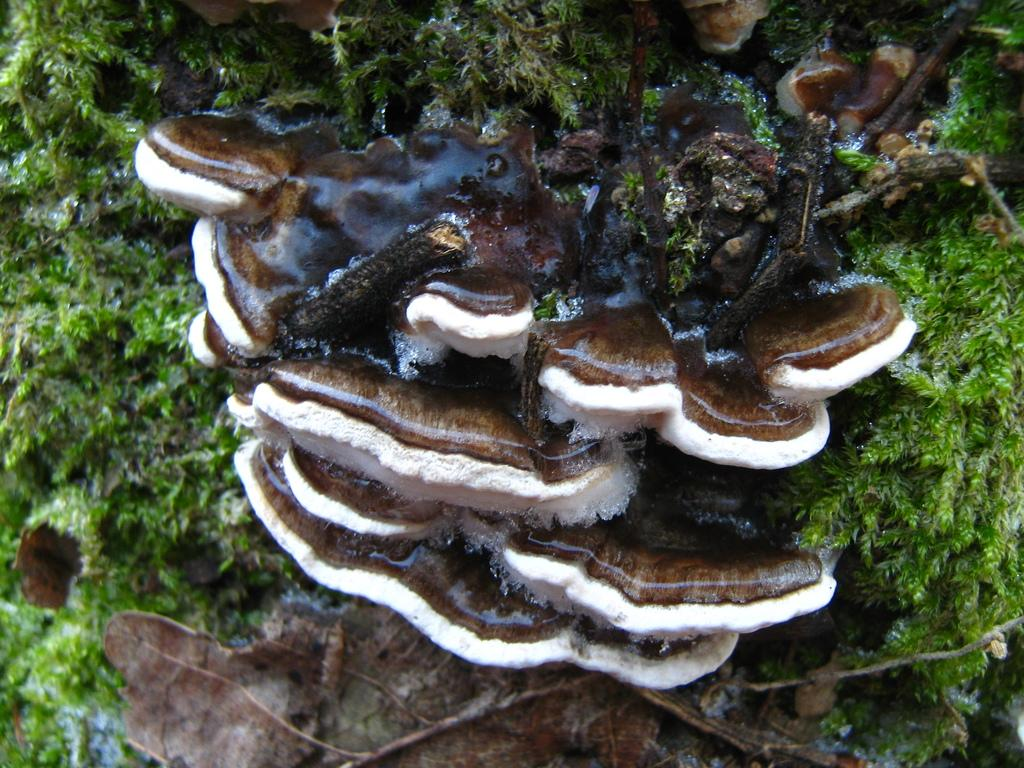What type of organism can be seen in the image? There is Tremellaceae, a type of fungi, in the image. What other living organism is present in the image? There is algae in the image. Is there a baby being born in the image? No, there is no baby or birth depicted in the image; it features Tremellaceae and algae. What type of cover is present in the image? There is no cover present in the image; it features Tremellaceae and algae. 